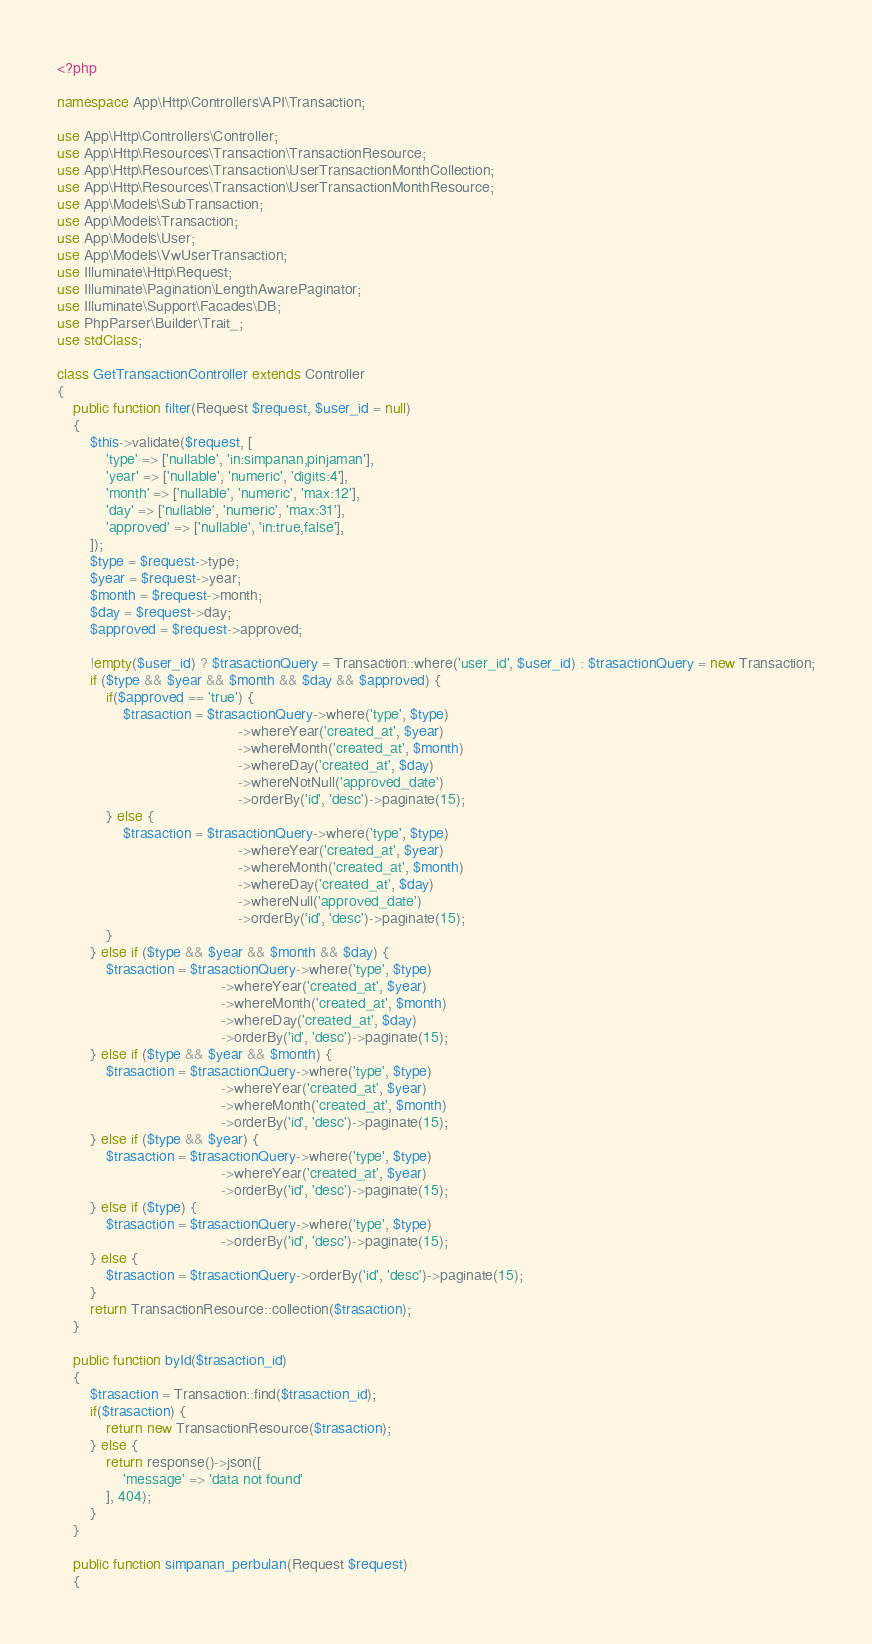Convert code to text. <code><loc_0><loc_0><loc_500><loc_500><_PHP_><?php

namespace App\Http\Controllers\API\Transaction;

use App\Http\Controllers\Controller;
use App\Http\Resources\Transaction\TransactionResource;
use App\Http\Resources\Transaction\UserTransactionMonthCollection;
use App\Http\Resources\Transaction\UserTransactionMonthResource;
use App\Models\SubTransaction;
use App\Models\Transaction;
use App\Models\User;
use App\Models\VwUserTransaction;
use Illuminate\Http\Request;
use Illuminate\Pagination\LengthAwarePaginator;
use Illuminate\Support\Facades\DB;
use PhpParser\Builder\Trait_;
use stdClass;

class GetTransactionController extends Controller
{
    public function filter(Request $request, $user_id = null)
    {
        $this->validate($request, [
            'type' => ['nullable', 'in:simpanan,pinjaman'],
            'year' => ['nullable', 'numeric', 'digits:4'],
            'month' => ['nullable', 'numeric', 'max:12'],
            'day' => ['nullable', 'numeric', 'max:31'],
            'approved' => ['nullable', 'in:true,false'],
        ]);
        $type = $request->type;
        $year = $request->year;
        $month = $request->month;
        $day = $request->day;
        $approved = $request->approved;

        !empty($user_id) ? $trasactionQuery = Transaction::where('user_id', $user_id) : $trasactionQuery = new Transaction;
        if ($type && $year && $month && $day && $approved) {
            if($approved == 'true') {
                $trasaction = $trasactionQuery->where('type', $type)
                                            ->whereYear('created_at', $year)
                                            ->whereMonth('created_at', $month)
                                            ->whereDay('created_at', $day)
                                            ->whereNotNull('approved_date')
                                            ->orderBy('id', 'desc')->paginate(15);
            } else {
                $trasaction = $trasactionQuery->where('type', $type)
                                            ->whereYear('created_at', $year)
                                            ->whereMonth('created_at', $month)
                                            ->whereDay('created_at', $day)
                                            ->whereNull('approved_date')
                                            ->orderBy('id', 'desc')->paginate(15);
            }
        } else if ($type && $year && $month && $day) {
            $trasaction = $trasactionQuery->where('type', $type)
                                        ->whereYear('created_at', $year)
                                        ->whereMonth('created_at', $month)
                                        ->whereDay('created_at', $day)
                                        ->orderBy('id', 'desc')->paginate(15);
        } else if ($type && $year && $month) {
            $trasaction = $trasactionQuery->where('type', $type)
                                        ->whereYear('created_at', $year)
                                        ->whereMonth('created_at', $month)
                                        ->orderBy('id', 'desc')->paginate(15);
        } else if ($type && $year) {
            $trasaction = $trasactionQuery->where('type', $type)
                                        ->whereYear('created_at', $year)
                                        ->orderBy('id', 'desc')->paginate(15);
        } else if ($type) {
            $trasaction = $trasactionQuery->where('type', $type)
                                        ->orderBy('id', 'desc')->paginate(15);
        } else {
            $trasaction = $trasactionQuery->orderBy('id', 'desc')->paginate(15);
        }
        return TransactionResource::collection($trasaction);
    }

    public function byId($trasaction_id)
    {
        $trasaction = Transaction::find($trasaction_id);
        if($trasaction) {
            return new TransactionResource($trasaction);
        } else {
            return response()->json([
                'message' => 'data not found'
            ], 404);
        }
    }

    public function simpanan_perbulan(Request $request)
    {</code> 